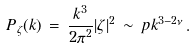<formula> <loc_0><loc_0><loc_500><loc_500>P _ { \zeta } ( k ) \, = \, { \frac { k ^ { 3 } } { 2 \pi ^ { 2 } } } | \zeta | ^ { 2 } \, \sim \, p k ^ { 3 - 2 \nu } \, .</formula> 